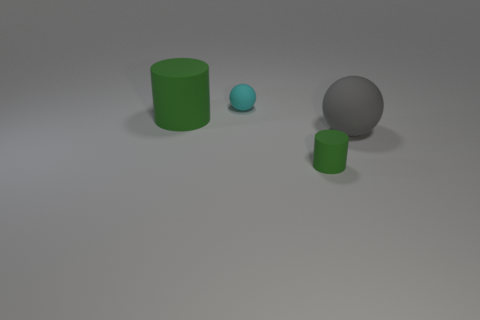Add 3 big brown metallic cylinders. How many objects exist? 7 Subtract 0 blue spheres. How many objects are left? 4 Subtract all green matte cylinders. Subtract all blocks. How many objects are left? 2 Add 4 small cyan matte things. How many small cyan matte things are left? 5 Add 3 large balls. How many large balls exist? 4 